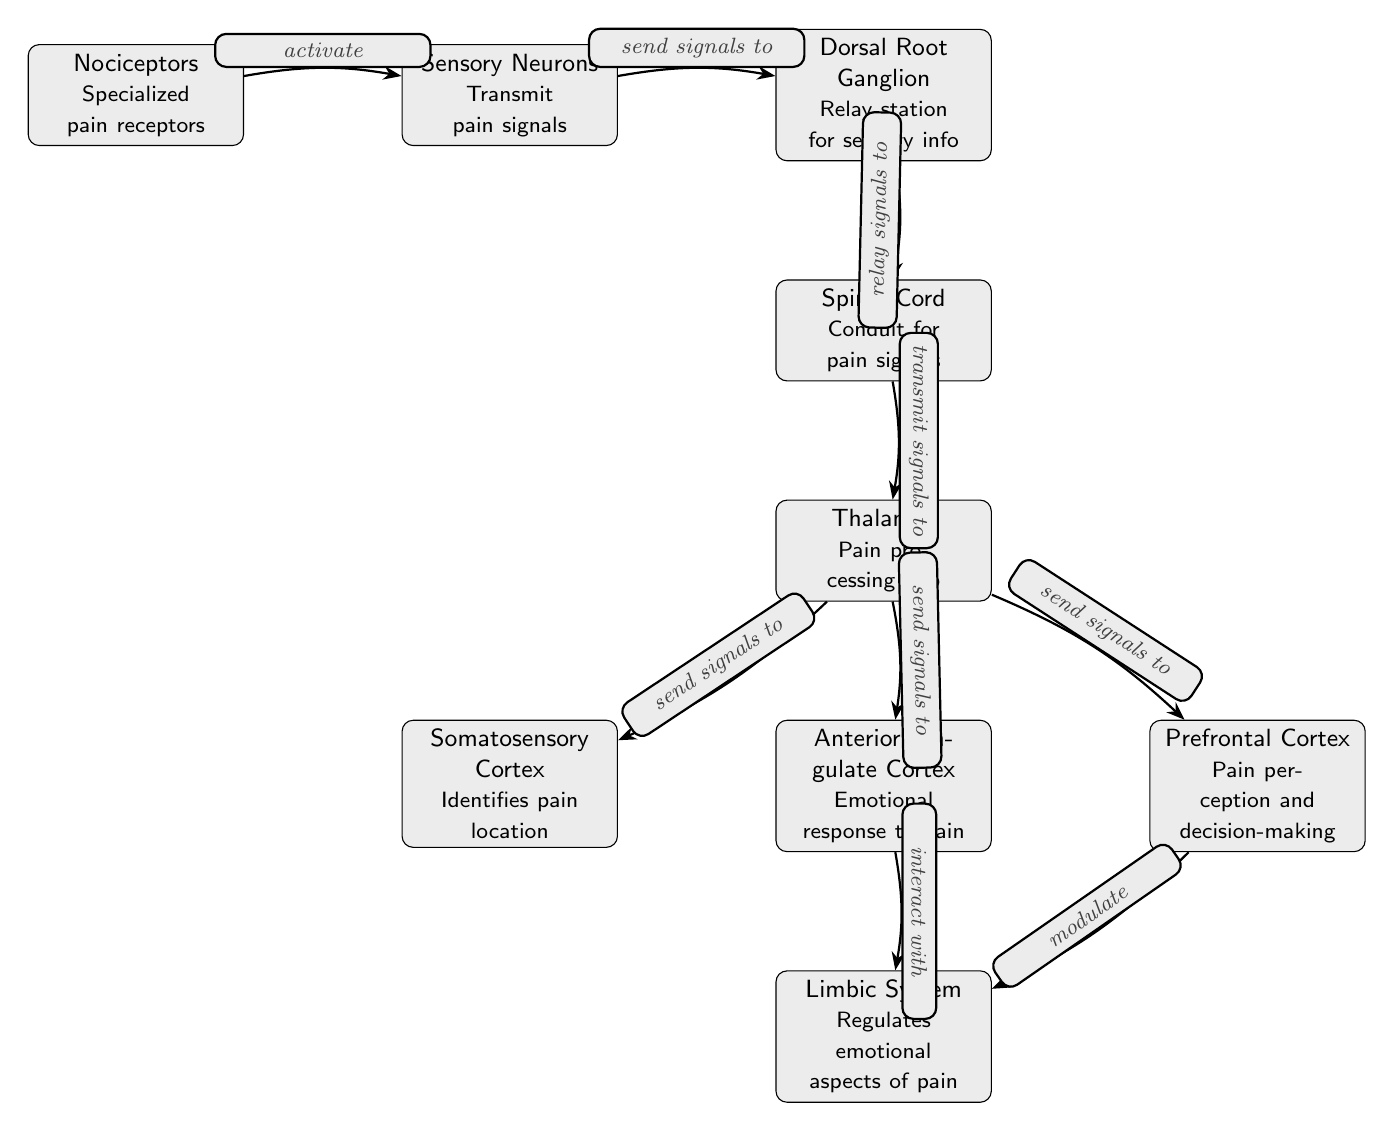What are nociceptors? Nociceptors are described as "Specialized pain receptors" in the diagram.
Answer: Specialized pain receptors How many key brain regions are shown in the diagram? The diagram includes four key brain regions: Somatosensory Cortex, Anterior Cingulate Cortex, Prefrontal Cortex, and Limbic System, all of which are connected to the Thalamus.
Answer: Four What role does the Thalamus play in the pain pathway? The Thalamus is identified as the "Pain processing hub" in the diagram, indicating its central role in processing pain signals.
Answer: Pain processing hub Which structure interacts with the Anterior Cingulate Cortex? The diagram shows that the Anterior Cingulate Cortex "interacts with" the Limbic System, indicating a connection between these two structures.
Answer: Limbic System What kind of signals do Sensory Neurons send to the Dorsal Root Ganglion? Sensory Neurons "send signals to" the Dorsal Root Ganglion in the diagram, conveying that they transmit pain signals received from nociceptors.
Answer: Pain signals How does the Prefrontal Cortex influence the Limbic System according to the diagram? The Prefrontal Cortex is labeled as being able to "modulate" the Limbic System, implying a regulatory effect on emotional responses to pain.
Answer: Modulate What is the function of the Spinal Cord in pain processing? The Spinal Cord serves as a "Conduit for pain signals," demonstrated in the diagram as it transmits signals from the Dorsal Root Ganglion to the Thalamus.
Answer: Conduit for pain signals What is the relationship between the Thalamus and the Somatosensory Cortex? The Thalamus "sends signals to" the Somatosensory Cortex, indicating that the Thalamus relays processed pain information for localization by this cortex.
Answer: Send signals to What do Sensory Neurons transmit? Sensory Neurons are described as transmitting "pain signals," showing their primary function in this neural pathway.
Answer: Pain signals 